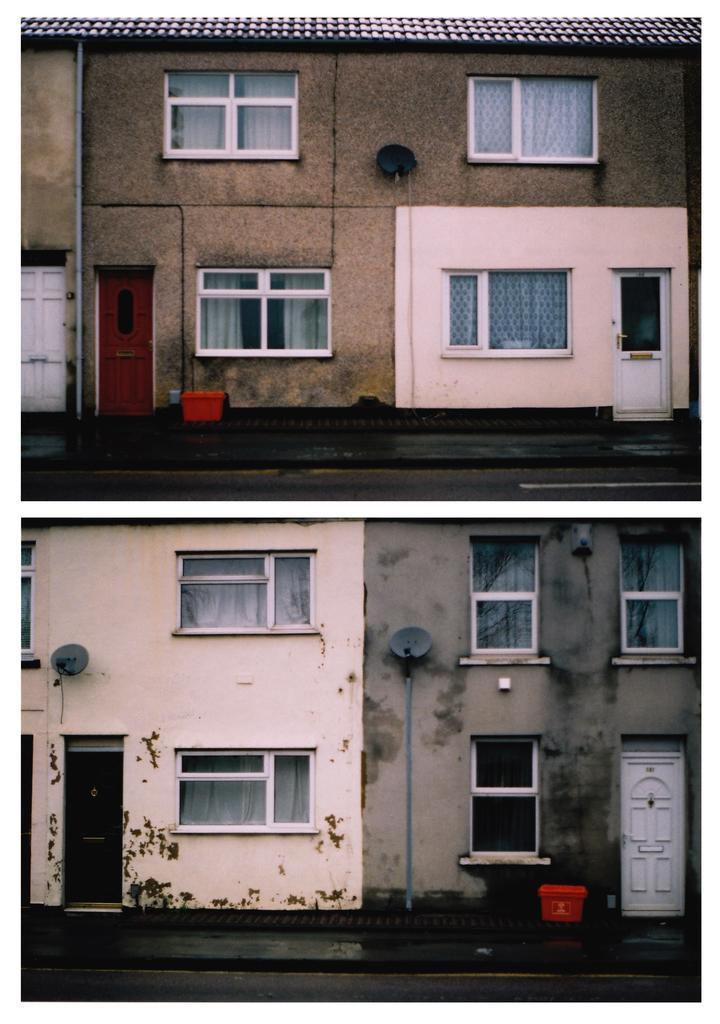How would you summarize this image in a sentence or two? In this image, at the right side bottom, there is a house, there are some white color glass windows and there is a white color door, at the left side bottom there is a house and there are some windows, there is a black color door, at the left side top there is a house and there are some windows and there is a white color door. 